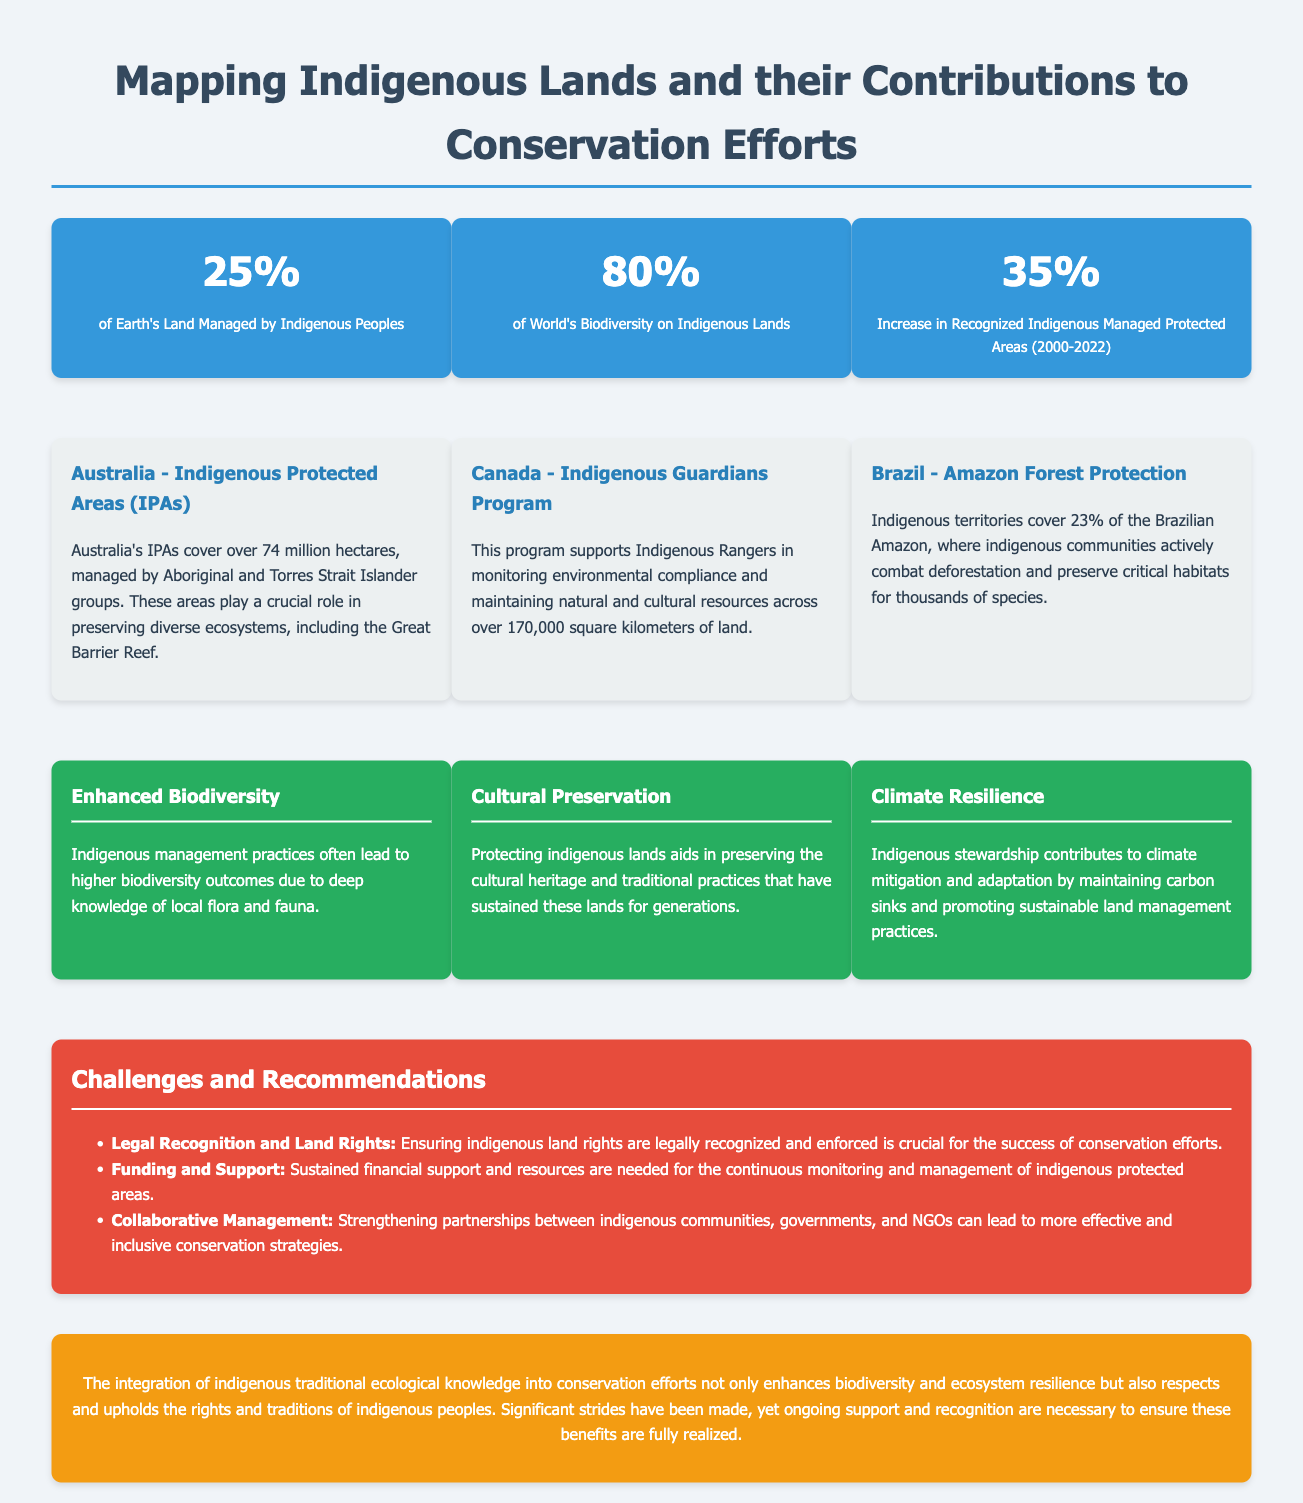What percentage of Earth's land is managed by Indigenous peoples? The document states that 25% of Earth's land is managed by Indigenous peoples.
Answer: 25% What is the increase in recognized Indigenous managed protected areas from 2000 to 2022? The document mentions a 35% increase in recognized Indigenous managed protected areas during this period.
Answer: 35% What percentage of the world's biodiversity is found on Indigenous lands? According to the infographic, 80% of the world's biodiversity is located on Indigenous lands.
Answer: 80% How many hectares do Australia's Indigenous Protected Areas cover? The document specifies that Australia's Indigenous Protected Areas cover over 74 million hectares.
Answer: 74 million hectares What is one challenge mentioned in the infographic related to Indigenous land conservation? The infographic highlights the challenge of Legal Recognition and Land Rights for effective conservation efforts.
Answer: Legal Recognition and Land Rights What program supports Indigenous Rangers in Canada? The document refers to the Indigenous Guardians Program as the initiative that supports Indigenous Rangers in Canada.
Answer: Indigenous Guardians Program What benefit results from Indigenous management practices according to the document? The document states that Indigenous management practices often lead to Enhanced Biodiversity outcomes.
Answer: Enhanced Biodiversity What is one recommendation for improving conservation efforts? The document suggests strengthening partnerships for more effective and inclusive conservation strategies as a recommendation.
Answer: Collaborative Management What color is used for the benefit boxes in the infographic? The benefit boxes are colored green as indicated in the infographic.
Answer: Green 